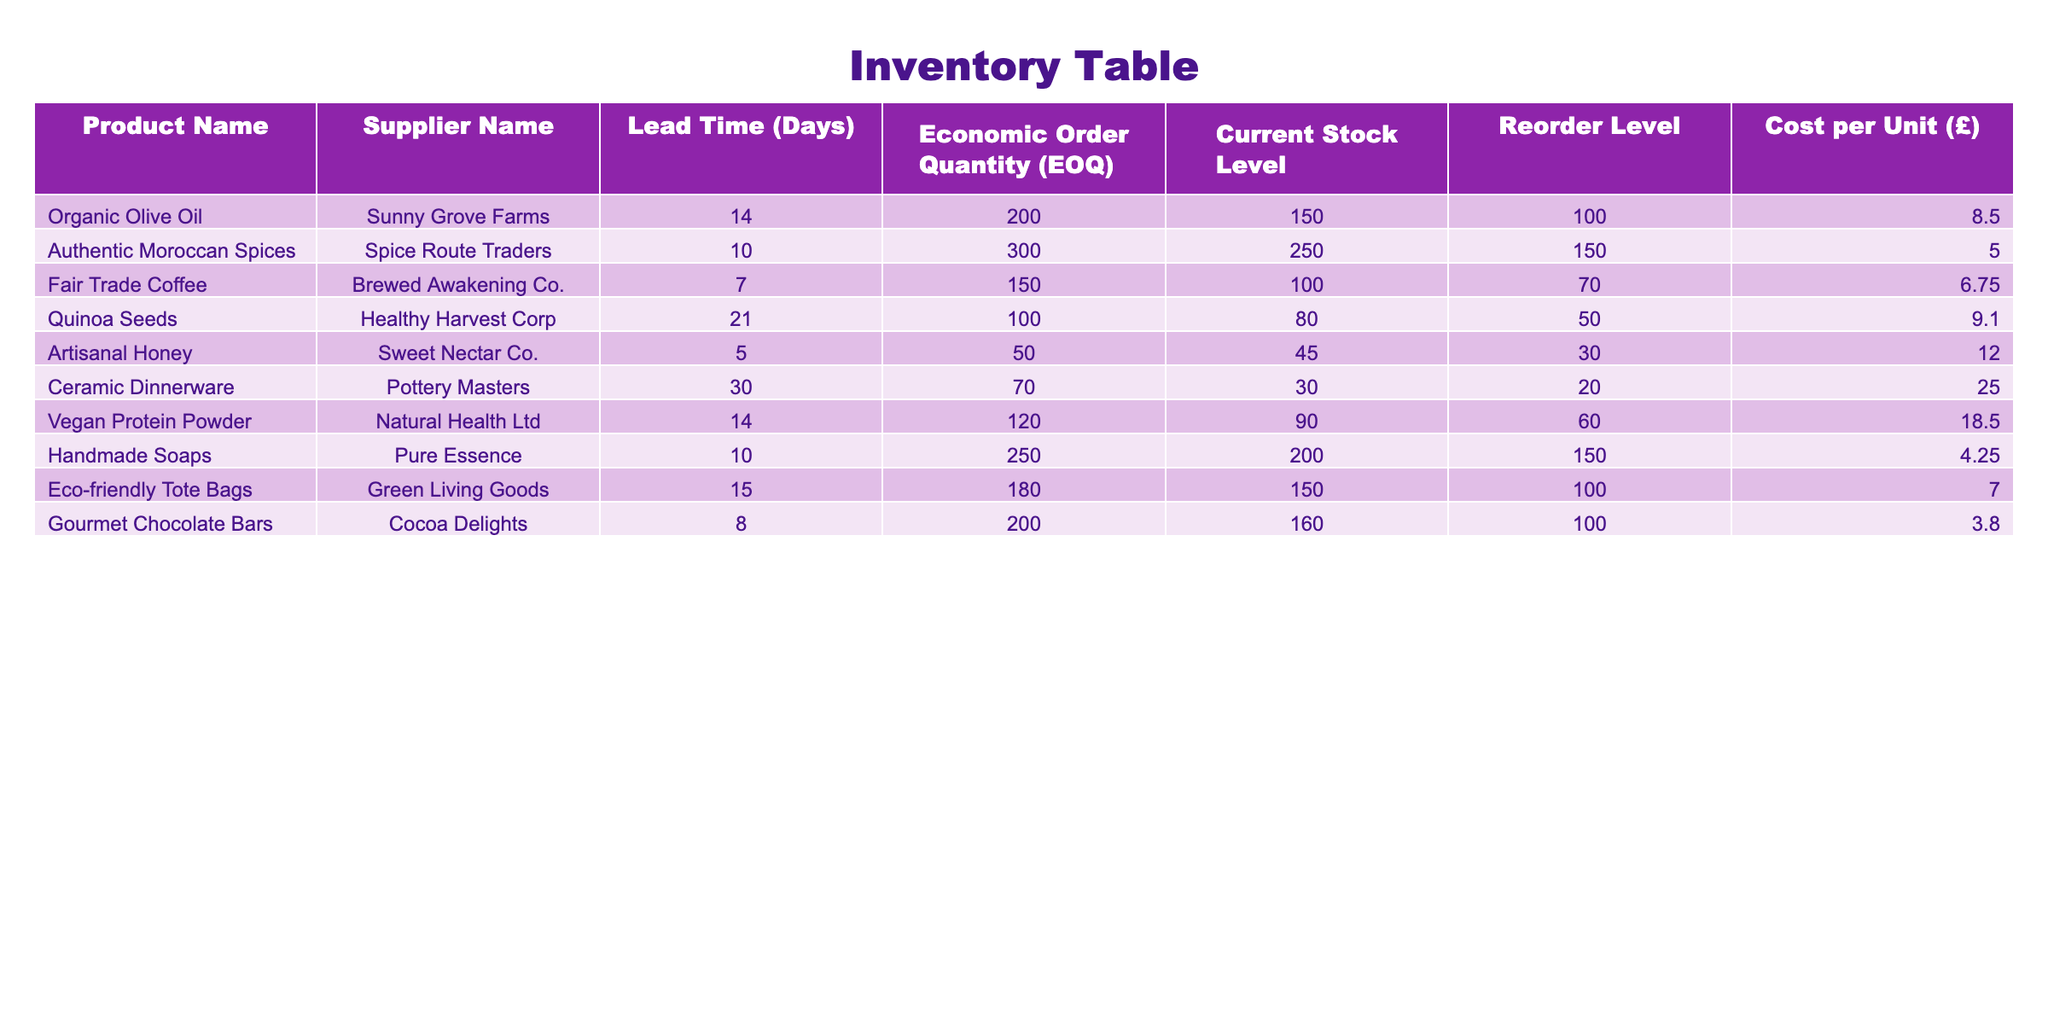What is the lead time for the Gourmet Chocolate Bars? According to the table, the lead time for the Gourmet Chocolate Bars is listed under the "Lead Time (Days)" column next to the product's name. This value is 8 days.
Answer: 8 days Which supplier has the longest lead time, and what is that lead time? By reviewing the "Lead Time (Days)" column, we can see that Ceramic Dinnerware has the highest lead time. The lead time for this product is 30 days.
Answer: Sunny Grove Farms, 30 days Is the current stock level of Vegan Protein Powder above the reorder level? The current stock level for Vegan Protein Powder is 90, and the reorder level is 60. Since 90 is greater than 60, this means the current stock exceeds the reorder level.
Answer: Yes What is the total cost per unit for Fair Trade Coffee and Authentic Moroccan Spices combined? To find the total cost per unit, we add the values found in the "Cost per Unit (£)" column for Fair Trade Coffee (£6.75) and Authentic Moroccan Spices (£5.00). This sums to £6.75 + £5.00 = £11.75.
Answer: £11.75 Does any supplier provide products with a lead time of less than 10 days? By examining the table, we can check each product's lead time. Both Fair Trade Coffee (7 days) and Artisanal Honey (5 days) have lead times less than 10 days, confirming that there are suppliers with such lead times.
Answer: Yes What is the average lead time of all products listed? To calculate the average lead time, we sum the lead times which are: 14 + 10 + 7 + 21 + 5 + 30 + 14 + 10 + 15 + 8 =  120 days. There are 10 products in total, so we divide the sum (120) by 10 to get an average of 12 days.
Answer: 12 days Which product has the highest reorder level, and what is that level? The reorder levels are listed under the "Reorder Level" column. Comparing these values, the Ceramic Dinnerware has the highest reorder level at 20.
Answer: Ceramic Dinnerware, 20 How many days lead time does Healthy Harvest Corp have compared to Brewed Awakening Co.? Healthy Harvest Corp has a lead time of 21 days for Quinoa Seeds, while Brewed Awakening Co. has a lead time of 7 days for Fair Trade Coffee. The difference is 21 - 7 = 14 days, meaning Healthy Harvest Corp has a lead time that is 14 days longer.
Answer: 14 days longer 